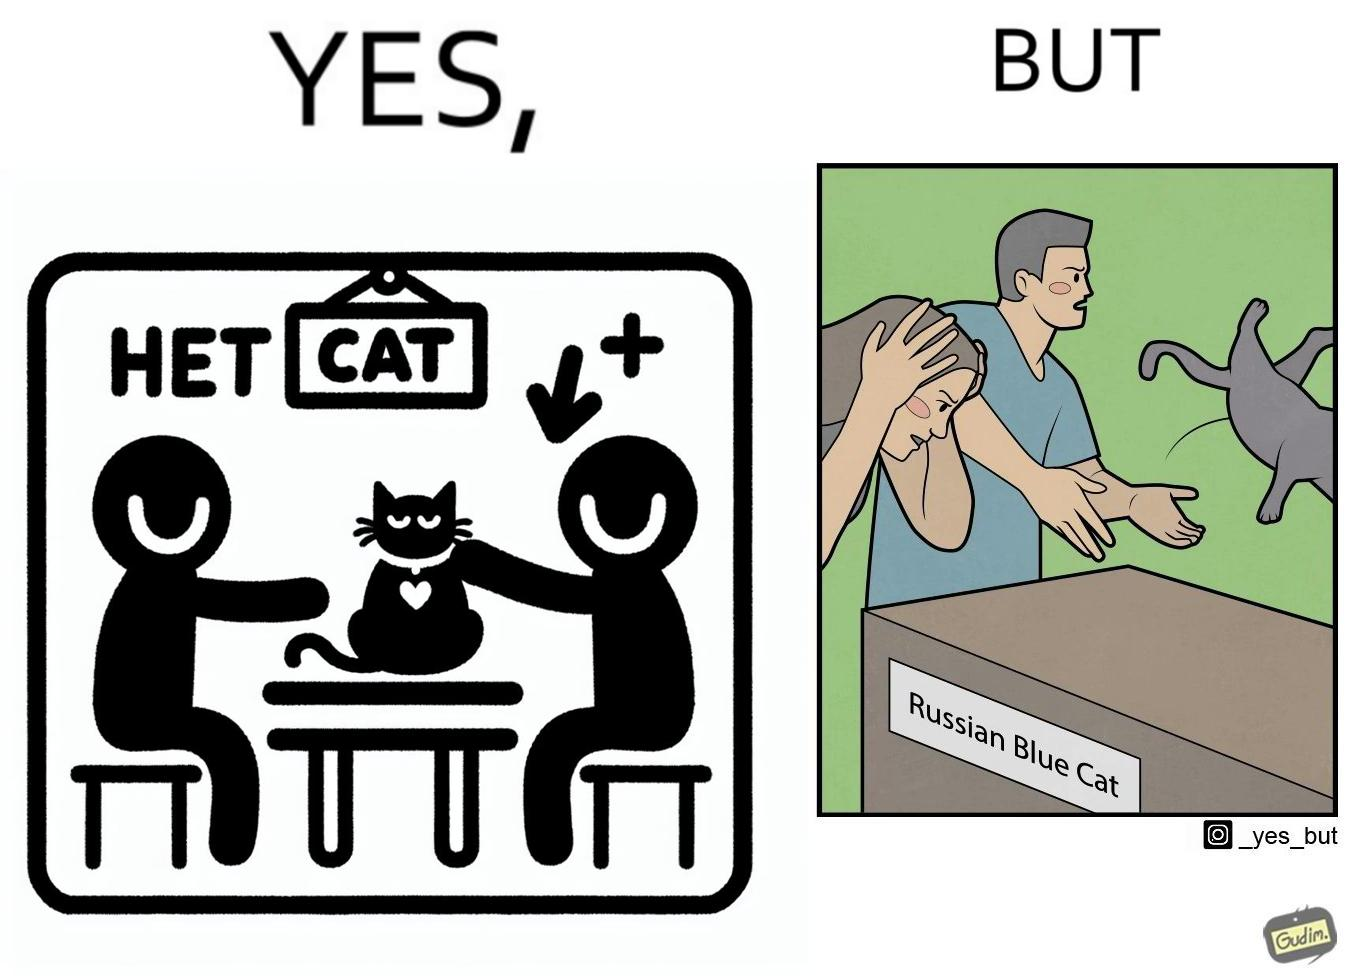Is this image satirical or non-satirical? Yes, this image is satirical. 